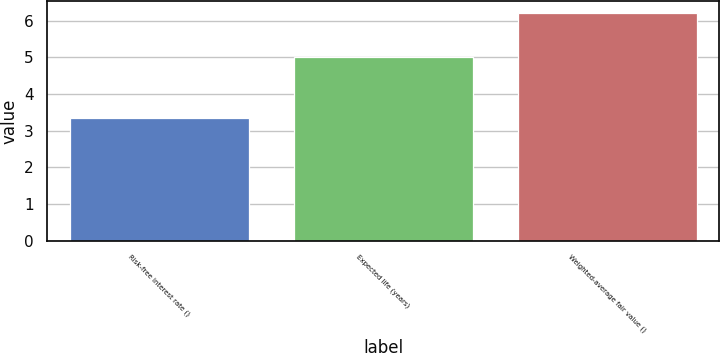Convert chart. <chart><loc_0><loc_0><loc_500><loc_500><bar_chart><fcel>Risk-free interest rate ()<fcel>Expected life (years)<fcel>Weighted-average fair value ()<nl><fcel>3.34<fcel>5<fcel>6.22<nl></chart> 